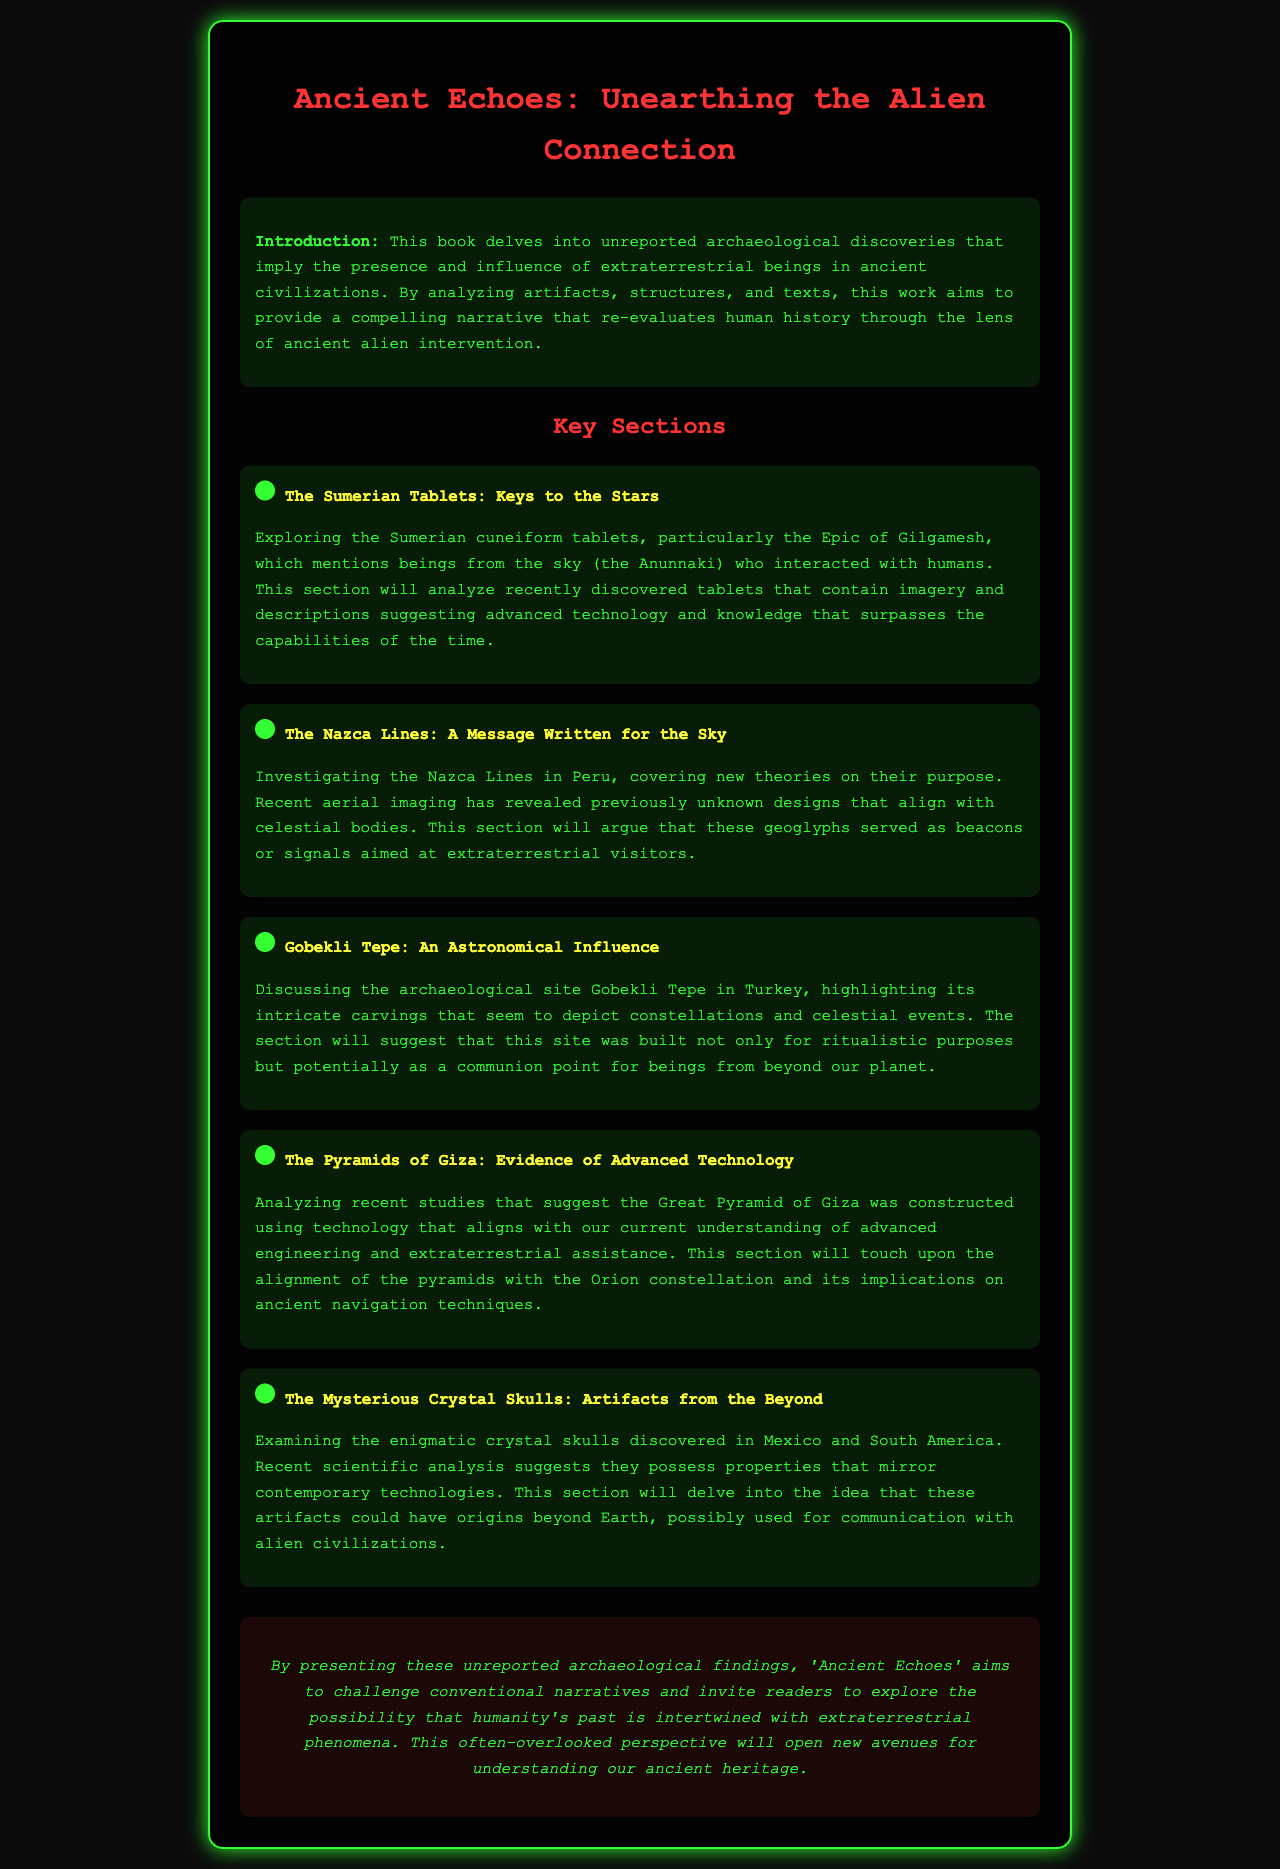What is the title of the book? The title of the book is stated at the top of the document.
Answer: Ancient Echoes: Unearthing the Alien Connection What ancient civilization is highlighted in the section about the Sumerian Tablets? This information is found in the section discussing the Sumerian Tablets.
Answer: Sumerian What recent technology is mentioned in relation to the Pyramids of Giza? The document refers to studies suggesting the use of advanced technology concerning construction methods.
Answer: Advanced technology Which archaeological site is suggested to depict constellations? The site is specifically discussed in the section about astronomical influences.
Answer: Gobekli Tepe What do the recent aerial imaging findings reveal about the Nazca Lines? The document explains that these findings have unveiled previously unseen designs related to celestial bodies.
Answer: Unknown designs What common theme connects the sections of the book? Each section discusses artifacts or sites and their potential link to extraterrestrial influence.
Answer: Extraterrestrial influence How many sections are listed under Key Sections? The document lists several distinct sections pertaining to various archaeological topics.
Answer: Five What is the primary aim of the book, as stated in the conclusion? This goal is outlined in the concluding statement regarding the book's narrative.
Answer: Challenge conventional narratives 